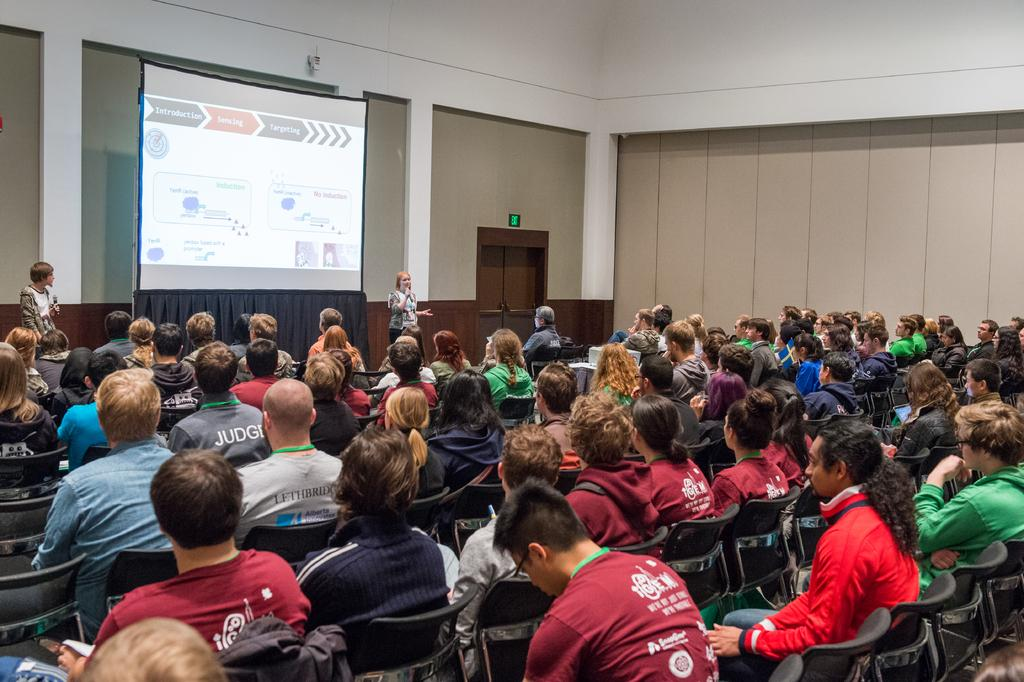What are the people in the image doing? There are people sitting on chairs and some people are standing in the image. What can be seen on the board in the image? There is a written text on a board in the image. What architectural feature is visible in the image? There is a door visible in the image. What type of background is present in the image? There is a wall in the image. What type of clouds can be seen in the image? There are no clouds visible in the image. How does the taste of the text on the board affect the people in the image? The text on the board does not have a taste, as it is not a food item. 